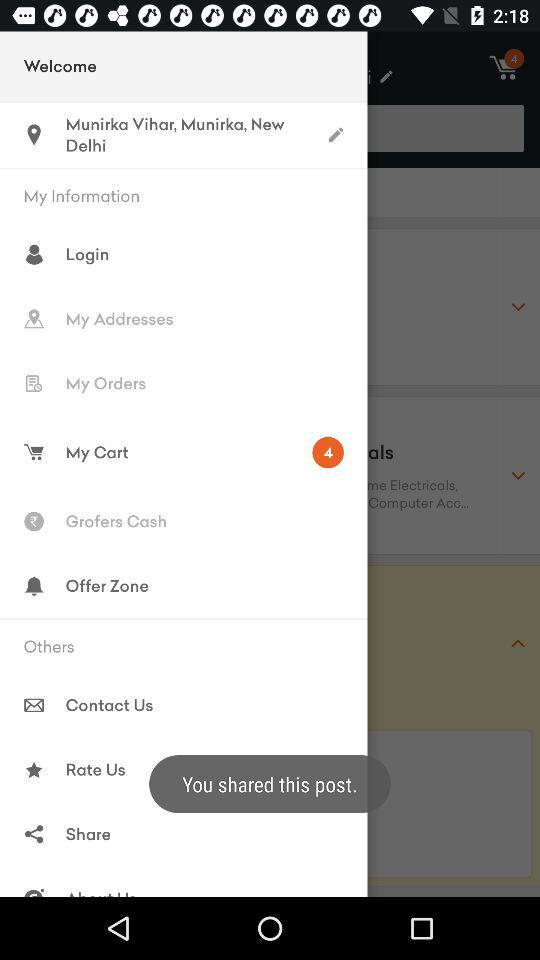How many items are in "My cart"? There are 4 items. 